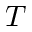Convert formula to latex. <formula><loc_0><loc_0><loc_500><loc_500>T</formula> 